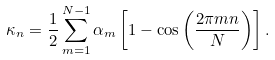<formula> <loc_0><loc_0><loc_500><loc_500>\kappa _ { n } = \frac { 1 } { 2 } \sum _ { m = 1 } ^ { N - 1 } \alpha _ { m } \left [ 1 - \cos \left ( \frac { 2 \pi m n } { N } \right ) \right ] .</formula> 